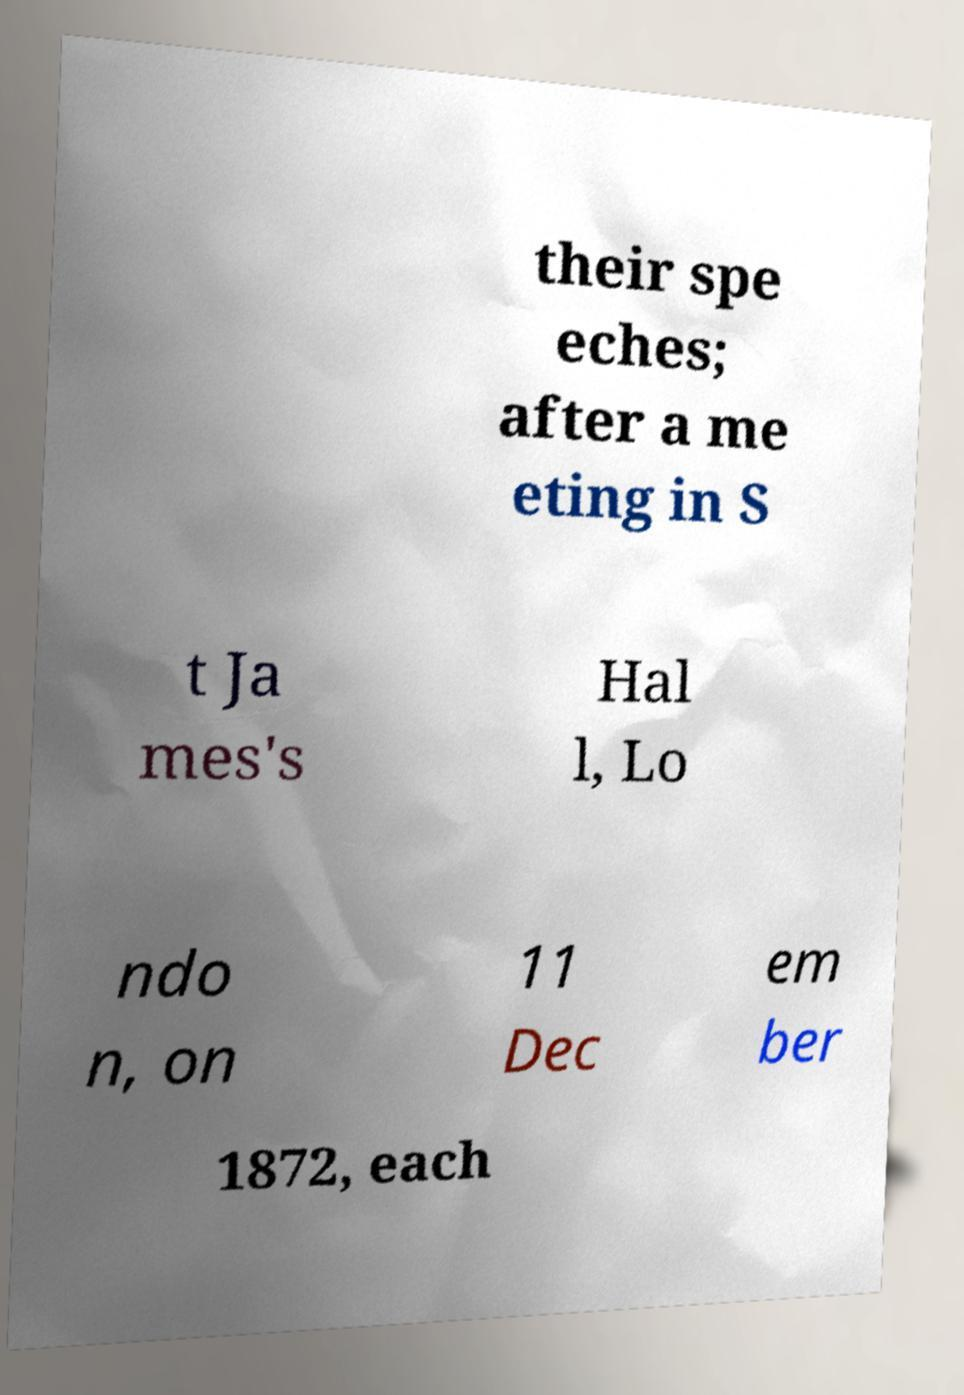For documentation purposes, I need the text within this image transcribed. Could you provide that? their spe eches; after a me eting in S t Ja mes's Hal l, Lo ndo n, on 11 Dec em ber 1872, each 